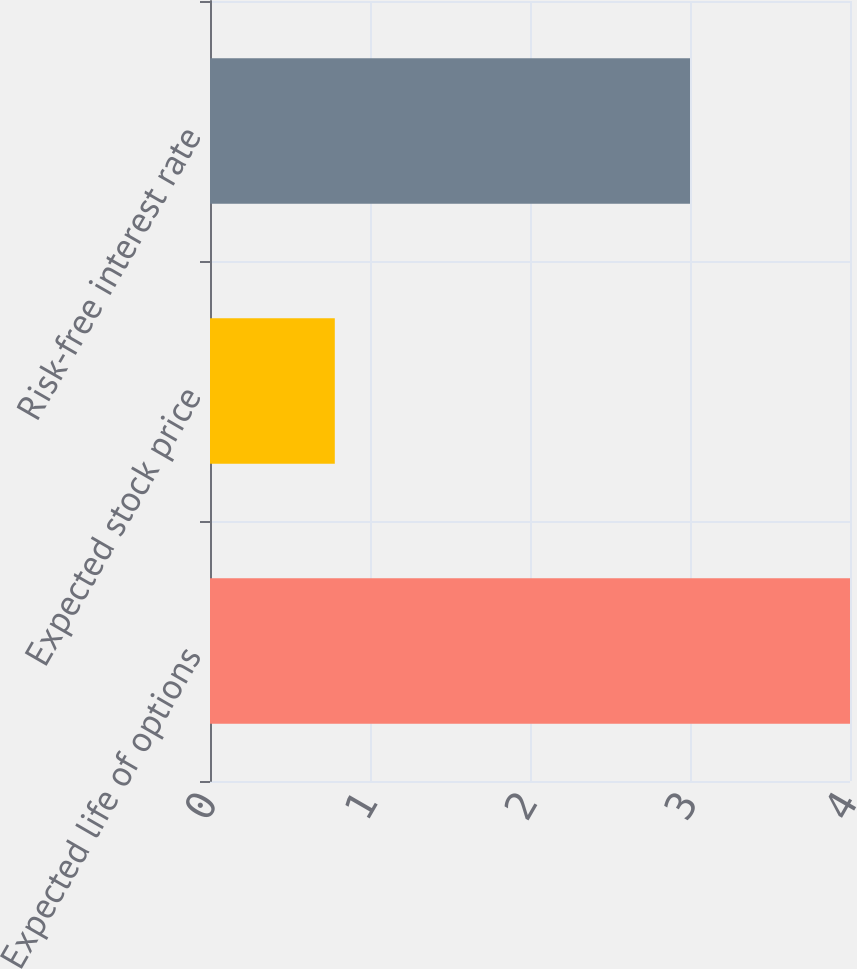Convert chart. <chart><loc_0><loc_0><loc_500><loc_500><bar_chart><fcel>Expected life of options<fcel>Expected stock price<fcel>Risk-free interest rate<nl><fcel>4<fcel>0.78<fcel>3<nl></chart> 